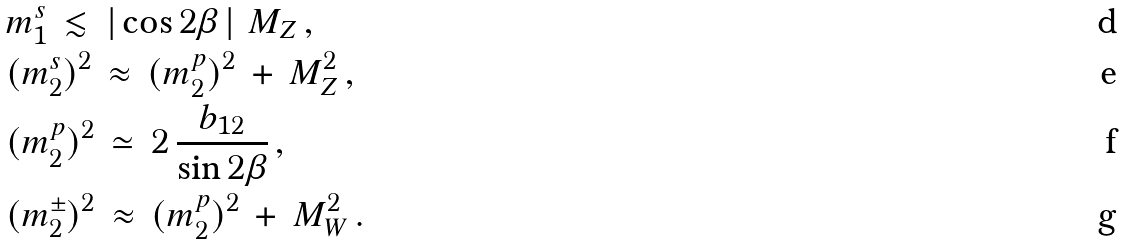Convert formula to latex. <formula><loc_0><loc_0><loc_500><loc_500>& m ^ { s } _ { 1 } \, \lesssim \, \left | \, \cos 2 \beta \, \right | \, M _ { Z } \, , \\ & ( m ^ { s } _ { 2 } ) ^ { 2 } \, \approx \, ( m ^ { p } _ { 2 } ) ^ { 2 } \, + \, M _ { Z } ^ { 2 } \, , \\ & ( m ^ { p } _ { 2 } ) ^ { 2 } \, \simeq \, 2 \, \frac { b _ { 1 2 } } { \sin 2 \beta } \, , \\ & ( m ^ { \pm } _ { 2 } ) ^ { 2 } \, \approx \, ( m ^ { p } _ { 2 } ) ^ { 2 } \, + \, M _ { W } ^ { 2 } \, .</formula> 